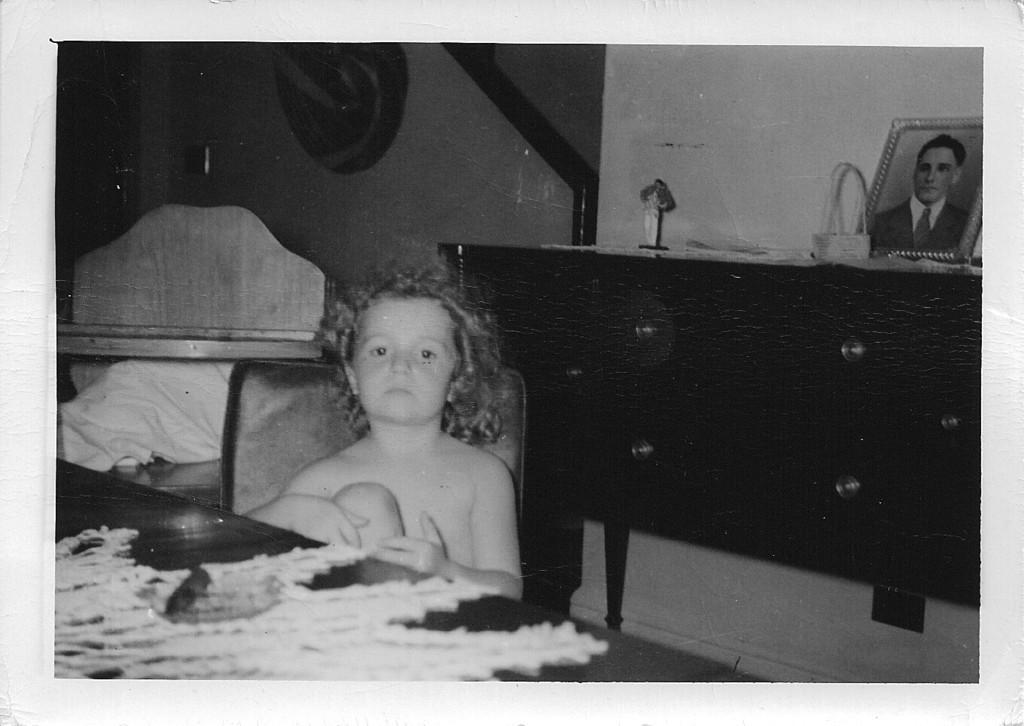Please provide a concise description of this image. In the foreground I can see a boy is sitting on a chair in front of a table. In the background I can see a table on which a basket, statue, photo frame is there and a wall. This image is taken may be in a hall. 